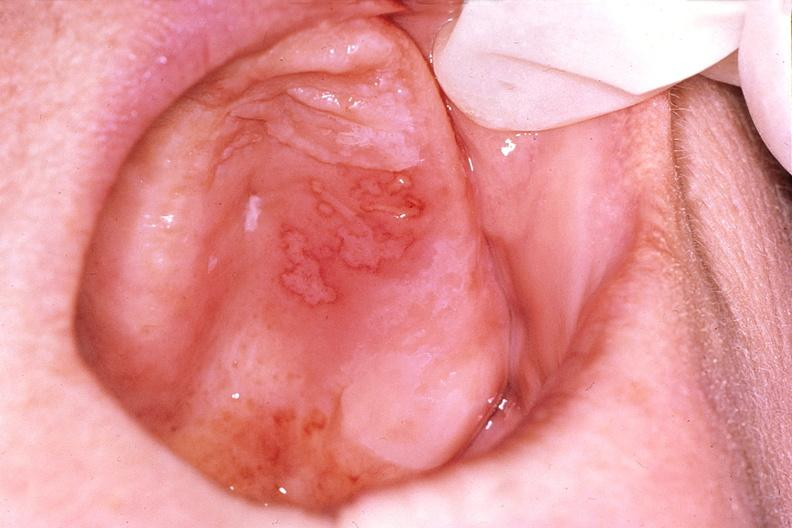what is present?
Answer the question using a single word or phrase. Gastrointestinal 